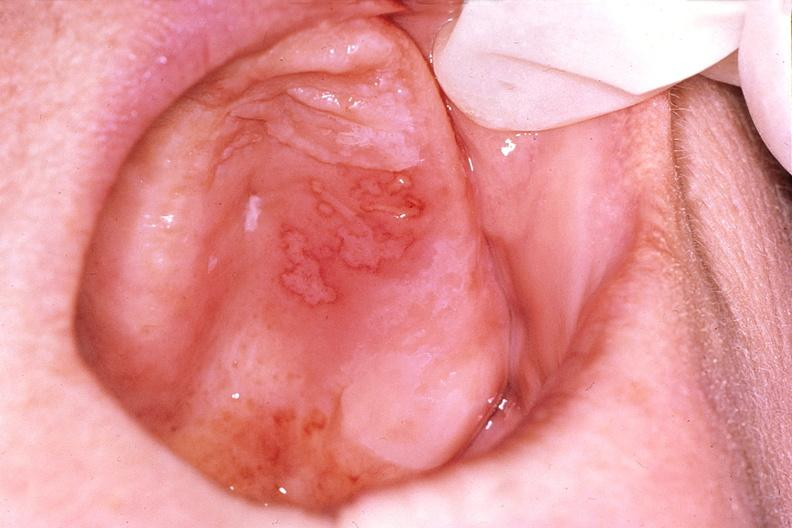what is present?
Answer the question using a single word or phrase. Gastrointestinal 